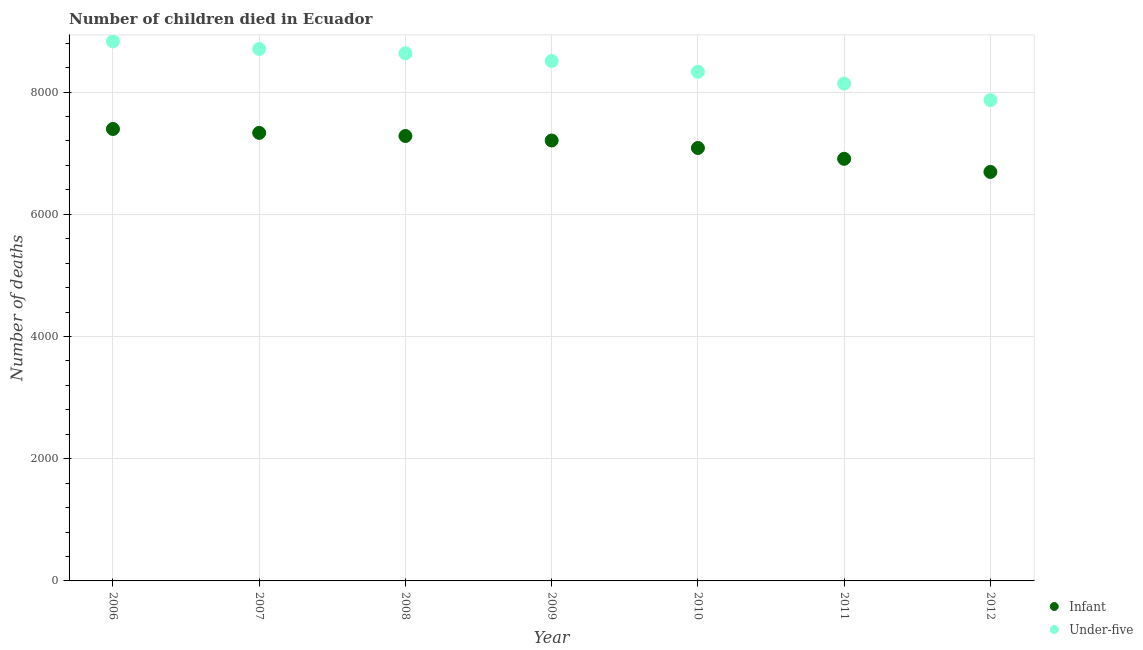Is the number of dotlines equal to the number of legend labels?
Offer a very short reply. Yes. What is the number of under-five deaths in 2011?
Your answer should be very brief. 8139. Across all years, what is the maximum number of infant deaths?
Provide a short and direct response. 7396. Across all years, what is the minimum number of infant deaths?
Your answer should be very brief. 6693. In which year was the number of infant deaths maximum?
Make the answer very short. 2006. In which year was the number of infant deaths minimum?
Offer a terse response. 2012. What is the total number of under-five deaths in the graph?
Ensure brevity in your answer.  5.90e+04. What is the difference between the number of under-five deaths in 2006 and that in 2007?
Provide a succinct answer. 123. What is the difference between the number of infant deaths in 2007 and the number of under-five deaths in 2008?
Your response must be concise. -1302. What is the average number of under-five deaths per year?
Your answer should be very brief. 8430.86. In the year 2010, what is the difference between the number of infant deaths and number of under-five deaths?
Your answer should be very brief. -1247. In how many years, is the number of under-five deaths greater than 5200?
Your response must be concise. 7. What is the ratio of the number of infant deaths in 2006 to that in 2010?
Your response must be concise. 1.04. Is the number of under-five deaths in 2006 less than that in 2008?
Keep it short and to the point. No. Is the difference between the number of infant deaths in 2008 and 2010 greater than the difference between the number of under-five deaths in 2008 and 2010?
Keep it short and to the point. No. What is the difference between the highest and the lowest number of infant deaths?
Offer a terse response. 703. In how many years, is the number of infant deaths greater than the average number of infant deaths taken over all years?
Your answer should be compact. 4. Does the number of infant deaths monotonically increase over the years?
Offer a very short reply. No. How many years are there in the graph?
Keep it short and to the point. 7. How many legend labels are there?
Give a very brief answer. 2. What is the title of the graph?
Make the answer very short. Number of children died in Ecuador. Does "Chemicals" appear as one of the legend labels in the graph?
Provide a succinct answer. No. What is the label or title of the X-axis?
Provide a short and direct response. Year. What is the label or title of the Y-axis?
Ensure brevity in your answer.  Number of deaths. What is the Number of deaths in Infant in 2006?
Make the answer very short. 7396. What is the Number of deaths of Under-five in 2006?
Your answer should be compact. 8829. What is the Number of deaths of Infant in 2007?
Offer a very short reply. 7332. What is the Number of deaths in Under-five in 2007?
Your response must be concise. 8706. What is the Number of deaths in Infant in 2008?
Give a very brief answer. 7281. What is the Number of deaths in Under-five in 2008?
Keep it short and to the point. 8634. What is the Number of deaths in Infant in 2009?
Make the answer very short. 7207. What is the Number of deaths of Under-five in 2009?
Your answer should be compact. 8508. What is the Number of deaths in Infant in 2010?
Your response must be concise. 7085. What is the Number of deaths in Under-five in 2010?
Give a very brief answer. 8332. What is the Number of deaths of Infant in 2011?
Your answer should be compact. 6908. What is the Number of deaths in Under-five in 2011?
Provide a short and direct response. 8139. What is the Number of deaths in Infant in 2012?
Offer a terse response. 6693. What is the Number of deaths in Under-five in 2012?
Your answer should be compact. 7868. Across all years, what is the maximum Number of deaths in Infant?
Provide a succinct answer. 7396. Across all years, what is the maximum Number of deaths in Under-five?
Give a very brief answer. 8829. Across all years, what is the minimum Number of deaths of Infant?
Keep it short and to the point. 6693. Across all years, what is the minimum Number of deaths in Under-five?
Provide a short and direct response. 7868. What is the total Number of deaths of Infant in the graph?
Keep it short and to the point. 4.99e+04. What is the total Number of deaths of Under-five in the graph?
Ensure brevity in your answer.  5.90e+04. What is the difference between the Number of deaths of Infant in 2006 and that in 2007?
Ensure brevity in your answer.  64. What is the difference between the Number of deaths of Under-five in 2006 and that in 2007?
Make the answer very short. 123. What is the difference between the Number of deaths of Infant in 2006 and that in 2008?
Make the answer very short. 115. What is the difference between the Number of deaths in Under-five in 2006 and that in 2008?
Make the answer very short. 195. What is the difference between the Number of deaths of Infant in 2006 and that in 2009?
Give a very brief answer. 189. What is the difference between the Number of deaths of Under-five in 2006 and that in 2009?
Ensure brevity in your answer.  321. What is the difference between the Number of deaths in Infant in 2006 and that in 2010?
Your answer should be compact. 311. What is the difference between the Number of deaths of Under-five in 2006 and that in 2010?
Your answer should be compact. 497. What is the difference between the Number of deaths of Infant in 2006 and that in 2011?
Your answer should be compact. 488. What is the difference between the Number of deaths of Under-five in 2006 and that in 2011?
Keep it short and to the point. 690. What is the difference between the Number of deaths in Infant in 2006 and that in 2012?
Keep it short and to the point. 703. What is the difference between the Number of deaths of Under-five in 2006 and that in 2012?
Ensure brevity in your answer.  961. What is the difference between the Number of deaths in Under-five in 2007 and that in 2008?
Give a very brief answer. 72. What is the difference between the Number of deaths of Infant in 2007 and that in 2009?
Make the answer very short. 125. What is the difference between the Number of deaths of Under-five in 2007 and that in 2009?
Your answer should be very brief. 198. What is the difference between the Number of deaths in Infant in 2007 and that in 2010?
Provide a succinct answer. 247. What is the difference between the Number of deaths of Under-five in 2007 and that in 2010?
Keep it short and to the point. 374. What is the difference between the Number of deaths of Infant in 2007 and that in 2011?
Offer a terse response. 424. What is the difference between the Number of deaths in Under-five in 2007 and that in 2011?
Provide a succinct answer. 567. What is the difference between the Number of deaths in Infant in 2007 and that in 2012?
Give a very brief answer. 639. What is the difference between the Number of deaths of Under-five in 2007 and that in 2012?
Ensure brevity in your answer.  838. What is the difference between the Number of deaths of Under-five in 2008 and that in 2009?
Provide a short and direct response. 126. What is the difference between the Number of deaths in Infant in 2008 and that in 2010?
Ensure brevity in your answer.  196. What is the difference between the Number of deaths in Under-five in 2008 and that in 2010?
Your answer should be compact. 302. What is the difference between the Number of deaths in Infant in 2008 and that in 2011?
Keep it short and to the point. 373. What is the difference between the Number of deaths in Under-five in 2008 and that in 2011?
Ensure brevity in your answer.  495. What is the difference between the Number of deaths of Infant in 2008 and that in 2012?
Give a very brief answer. 588. What is the difference between the Number of deaths of Under-five in 2008 and that in 2012?
Ensure brevity in your answer.  766. What is the difference between the Number of deaths in Infant in 2009 and that in 2010?
Make the answer very short. 122. What is the difference between the Number of deaths of Under-five in 2009 and that in 2010?
Offer a very short reply. 176. What is the difference between the Number of deaths of Infant in 2009 and that in 2011?
Your answer should be very brief. 299. What is the difference between the Number of deaths of Under-five in 2009 and that in 2011?
Your response must be concise. 369. What is the difference between the Number of deaths of Infant in 2009 and that in 2012?
Ensure brevity in your answer.  514. What is the difference between the Number of deaths of Under-five in 2009 and that in 2012?
Make the answer very short. 640. What is the difference between the Number of deaths in Infant in 2010 and that in 2011?
Your answer should be compact. 177. What is the difference between the Number of deaths in Under-five in 2010 and that in 2011?
Make the answer very short. 193. What is the difference between the Number of deaths in Infant in 2010 and that in 2012?
Keep it short and to the point. 392. What is the difference between the Number of deaths in Under-five in 2010 and that in 2012?
Give a very brief answer. 464. What is the difference between the Number of deaths in Infant in 2011 and that in 2012?
Your response must be concise. 215. What is the difference between the Number of deaths of Under-five in 2011 and that in 2012?
Ensure brevity in your answer.  271. What is the difference between the Number of deaths of Infant in 2006 and the Number of deaths of Under-five in 2007?
Make the answer very short. -1310. What is the difference between the Number of deaths in Infant in 2006 and the Number of deaths in Under-five in 2008?
Your answer should be very brief. -1238. What is the difference between the Number of deaths in Infant in 2006 and the Number of deaths in Under-five in 2009?
Your answer should be very brief. -1112. What is the difference between the Number of deaths in Infant in 2006 and the Number of deaths in Under-five in 2010?
Ensure brevity in your answer.  -936. What is the difference between the Number of deaths of Infant in 2006 and the Number of deaths of Under-five in 2011?
Ensure brevity in your answer.  -743. What is the difference between the Number of deaths of Infant in 2006 and the Number of deaths of Under-five in 2012?
Your answer should be compact. -472. What is the difference between the Number of deaths of Infant in 2007 and the Number of deaths of Under-five in 2008?
Ensure brevity in your answer.  -1302. What is the difference between the Number of deaths in Infant in 2007 and the Number of deaths in Under-five in 2009?
Keep it short and to the point. -1176. What is the difference between the Number of deaths of Infant in 2007 and the Number of deaths of Under-five in 2010?
Your answer should be compact. -1000. What is the difference between the Number of deaths in Infant in 2007 and the Number of deaths in Under-five in 2011?
Your answer should be compact. -807. What is the difference between the Number of deaths of Infant in 2007 and the Number of deaths of Under-five in 2012?
Make the answer very short. -536. What is the difference between the Number of deaths of Infant in 2008 and the Number of deaths of Under-five in 2009?
Make the answer very short. -1227. What is the difference between the Number of deaths of Infant in 2008 and the Number of deaths of Under-five in 2010?
Make the answer very short. -1051. What is the difference between the Number of deaths in Infant in 2008 and the Number of deaths in Under-five in 2011?
Your answer should be very brief. -858. What is the difference between the Number of deaths in Infant in 2008 and the Number of deaths in Under-five in 2012?
Provide a short and direct response. -587. What is the difference between the Number of deaths of Infant in 2009 and the Number of deaths of Under-five in 2010?
Your answer should be compact. -1125. What is the difference between the Number of deaths in Infant in 2009 and the Number of deaths in Under-five in 2011?
Your answer should be compact. -932. What is the difference between the Number of deaths in Infant in 2009 and the Number of deaths in Under-five in 2012?
Your answer should be compact. -661. What is the difference between the Number of deaths in Infant in 2010 and the Number of deaths in Under-five in 2011?
Give a very brief answer. -1054. What is the difference between the Number of deaths in Infant in 2010 and the Number of deaths in Under-five in 2012?
Offer a very short reply. -783. What is the difference between the Number of deaths of Infant in 2011 and the Number of deaths of Under-five in 2012?
Provide a succinct answer. -960. What is the average Number of deaths of Infant per year?
Provide a short and direct response. 7128.86. What is the average Number of deaths in Under-five per year?
Give a very brief answer. 8430.86. In the year 2006, what is the difference between the Number of deaths of Infant and Number of deaths of Under-five?
Your response must be concise. -1433. In the year 2007, what is the difference between the Number of deaths of Infant and Number of deaths of Under-five?
Your answer should be very brief. -1374. In the year 2008, what is the difference between the Number of deaths in Infant and Number of deaths in Under-five?
Give a very brief answer. -1353. In the year 2009, what is the difference between the Number of deaths of Infant and Number of deaths of Under-five?
Offer a terse response. -1301. In the year 2010, what is the difference between the Number of deaths in Infant and Number of deaths in Under-five?
Give a very brief answer. -1247. In the year 2011, what is the difference between the Number of deaths of Infant and Number of deaths of Under-five?
Provide a short and direct response. -1231. In the year 2012, what is the difference between the Number of deaths of Infant and Number of deaths of Under-five?
Offer a terse response. -1175. What is the ratio of the Number of deaths in Infant in 2006 to that in 2007?
Your answer should be compact. 1.01. What is the ratio of the Number of deaths of Under-five in 2006 to that in 2007?
Keep it short and to the point. 1.01. What is the ratio of the Number of deaths in Infant in 2006 to that in 2008?
Provide a succinct answer. 1.02. What is the ratio of the Number of deaths in Under-five in 2006 to that in 2008?
Provide a short and direct response. 1.02. What is the ratio of the Number of deaths of Infant in 2006 to that in 2009?
Provide a succinct answer. 1.03. What is the ratio of the Number of deaths in Under-five in 2006 to that in 2009?
Make the answer very short. 1.04. What is the ratio of the Number of deaths in Infant in 2006 to that in 2010?
Provide a short and direct response. 1.04. What is the ratio of the Number of deaths in Under-five in 2006 to that in 2010?
Give a very brief answer. 1.06. What is the ratio of the Number of deaths of Infant in 2006 to that in 2011?
Offer a terse response. 1.07. What is the ratio of the Number of deaths in Under-five in 2006 to that in 2011?
Your answer should be very brief. 1.08. What is the ratio of the Number of deaths of Infant in 2006 to that in 2012?
Provide a succinct answer. 1.1. What is the ratio of the Number of deaths of Under-five in 2006 to that in 2012?
Ensure brevity in your answer.  1.12. What is the ratio of the Number of deaths of Under-five in 2007 to that in 2008?
Give a very brief answer. 1.01. What is the ratio of the Number of deaths in Infant in 2007 to that in 2009?
Provide a succinct answer. 1.02. What is the ratio of the Number of deaths in Under-five in 2007 to that in 2009?
Make the answer very short. 1.02. What is the ratio of the Number of deaths in Infant in 2007 to that in 2010?
Keep it short and to the point. 1.03. What is the ratio of the Number of deaths of Under-five in 2007 to that in 2010?
Provide a succinct answer. 1.04. What is the ratio of the Number of deaths in Infant in 2007 to that in 2011?
Ensure brevity in your answer.  1.06. What is the ratio of the Number of deaths of Under-five in 2007 to that in 2011?
Your answer should be compact. 1.07. What is the ratio of the Number of deaths in Infant in 2007 to that in 2012?
Ensure brevity in your answer.  1.1. What is the ratio of the Number of deaths of Under-five in 2007 to that in 2012?
Keep it short and to the point. 1.11. What is the ratio of the Number of deaths in Infant in 2008 to that in 2009?
Keep it short and to the point. 1.01. What is the ratio of the Number of deaths of Under-five in 2008 to that in 2009?
Make the answer very short. 1.01. What is the ratio of the Number of deaths of Infant in 2008 to that in 2010?
Provide a succinct answer. 1.03. What is the ratio of the Number of deaths in Under-five in 2008 to that in 2010?
Provide a short and direct response. 1.04. What is the ratio of the Number of deaths of Infant in 2008 to that in 2011?
Keep it short and to the point. 1.05. What is the ratio of the Number of deaths of Under-five in 2008 to that in 2011?
Your answer should be very brief. 1.06. What is the ratio of the Number of deaths in Infant in 2008 to that in 2012?
Ensure brevity in your answer.  1.09. What is the ratio of the Number of deaths of Under-five in 2008 to that in 2012?
Offer a terse response. 1.1. What is the ratio of the Number of deaths in Infant in 2009 to that in 2010?
Offer a terse response. 1.02. What is the ratio of the Number of deaths in Under-five in 2009 to that in 2010?
Your answer should be compact. 1.02. What is the ratio of the Number of deaths of Infant in 2009 to that in 2011?
Give a very brief answer. 1.04. What is the ratio of the Number of deaths of Under-five in 2009 to that in 2011?
Ensure brevity in your answer.  1.05. What is the ratio of the Number of deaths in Infant in 2009 to that in 2012?
Offer a very short reply. 1.08. What is the ratio of the Number of deaths in Under-five in 2009 to that in 2012?
Offer a terse response. 1.08. What is the ratio of the Number of deaths in Infant in 2010 to that in 2011?
Offer a very short reply. 1.03. What is the ratio of the Number of deaths in Under-five in 2010 to that in 2011?
Provide a succinct answer. 1.02. What is the ratio of the Number of deaths in Infant in 2010 to that in 2012?
Your response must be concise. 1.06. What is the ratio of the Number of deaths in Under-five in 2010 to that in 2012?
Your response must be concise. 1.06. What is the ratio of the Number of deaths in Infant in 2011 to that in 2012?
Ensure brevity in your answer.  1.03. What is the ratio of the Number of deaths in Under-five in 2011 to that in 2012?
Provide a succinct answer. 1.03. What is the difference between the highest and the second highest Number of deaths of Infant?
Keep it short and to the point. 64. What is the difference between the highest and the second highest Number of deaths in Under-five?
Provide a short and direct response. 123. What is the difference between the highest and the lowest Number of deaths in Infant?
Provide a succinct answer. 703. What is the difference between the highest and the lowest Number of deaths in Under-five?
Offer a very short reply. 961. 